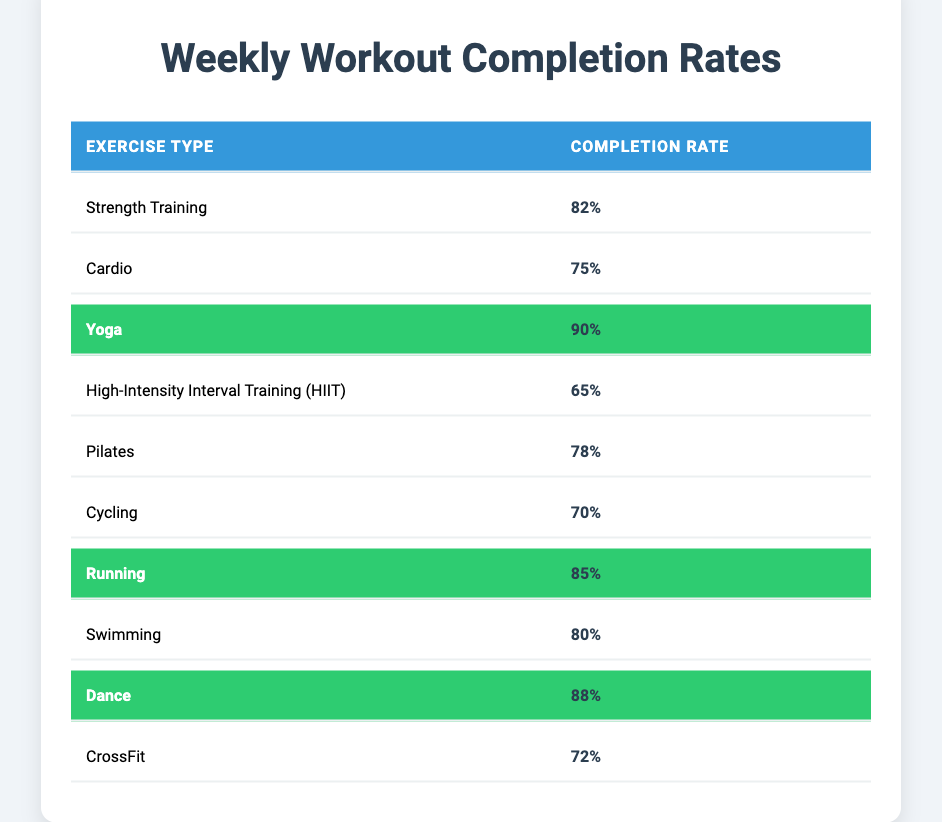What is the highest workout completion rate among the exercise types? Looking at the table, the completion rates for each exercise type indicate that Yoga has the highest completion rate at 90%.
Answer: 90% Which exercise type has a completion rate of 75%? The table shows that Cardio has a completion rate of 75%.
Answer: Cardio How many exercise types have a completion rate above 80%? Reviewing the completion rates, we find Yoga (90%), Running (85%), and Dance (88%), which totals three exercise types above 80%.
Answer: 3 What is the completion rate difference between Yoga and High-Intensity Interval Training (HIIT)? Yoga has a completion rate of 90% and HIIT has 65%. The difference is 90% - 65% = 25%.
Answer: 25% Is the completion rate of Swimming greater than that of Cycling? The completion rate for Swimming is 80% and for Cycling is 70%. Since 80% is greater than 70%, the statement is true.
Answer: True What is the average completion rate of all exercise types listed in the table? To find the average, we add all completion rates (82 + 75 + 90 + 65 + 78 + 70 + 85 + 80 + 88 + 72 =  810) and divide by 10 (number of exercise types), which gives us an average of 81%.
Answer: 81% Which exercise types have a completion rate less than 70%? The only exercise type with a completion rate under 70% is High-Intensity Interval Training (65%).
Answer: High-Intensity Interval Training Are there any exercise types that have the same completion rate? Reviewing the table, no exercise types have identical completion rates; each listed variety has a unique value.
Answer: No What are the completion rates for the two highlighted exercise types? The highlighted exercise types are Yoga (90%) and Dance (88%).
Answer: Yoga: 90%, Dance: 88% Which exercise type has a completion rate closest to the median value of the completion rates in the table? The completion rates, when ordered, are (65, 70, 72, 75, 78, 80, 82, 85, 88, 90). The median of these ten values is (78 + 80) / 2 = 79; the exercise type with the completion rate closest to this median is Pilates (78%).
Answer: Pilates (78%) 